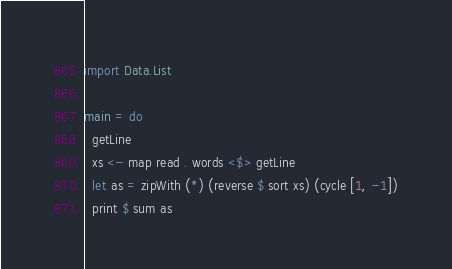<code> <loc_0><loc_0><loc_500><loc_500><_Haskell_>import Data.List

main = do
  getLine
  xs <- map read . words <$> getLine
  let as = zipWith (*) (reverse $ sort xs) (cycle [1, -1])
  print $ sum as</code> 